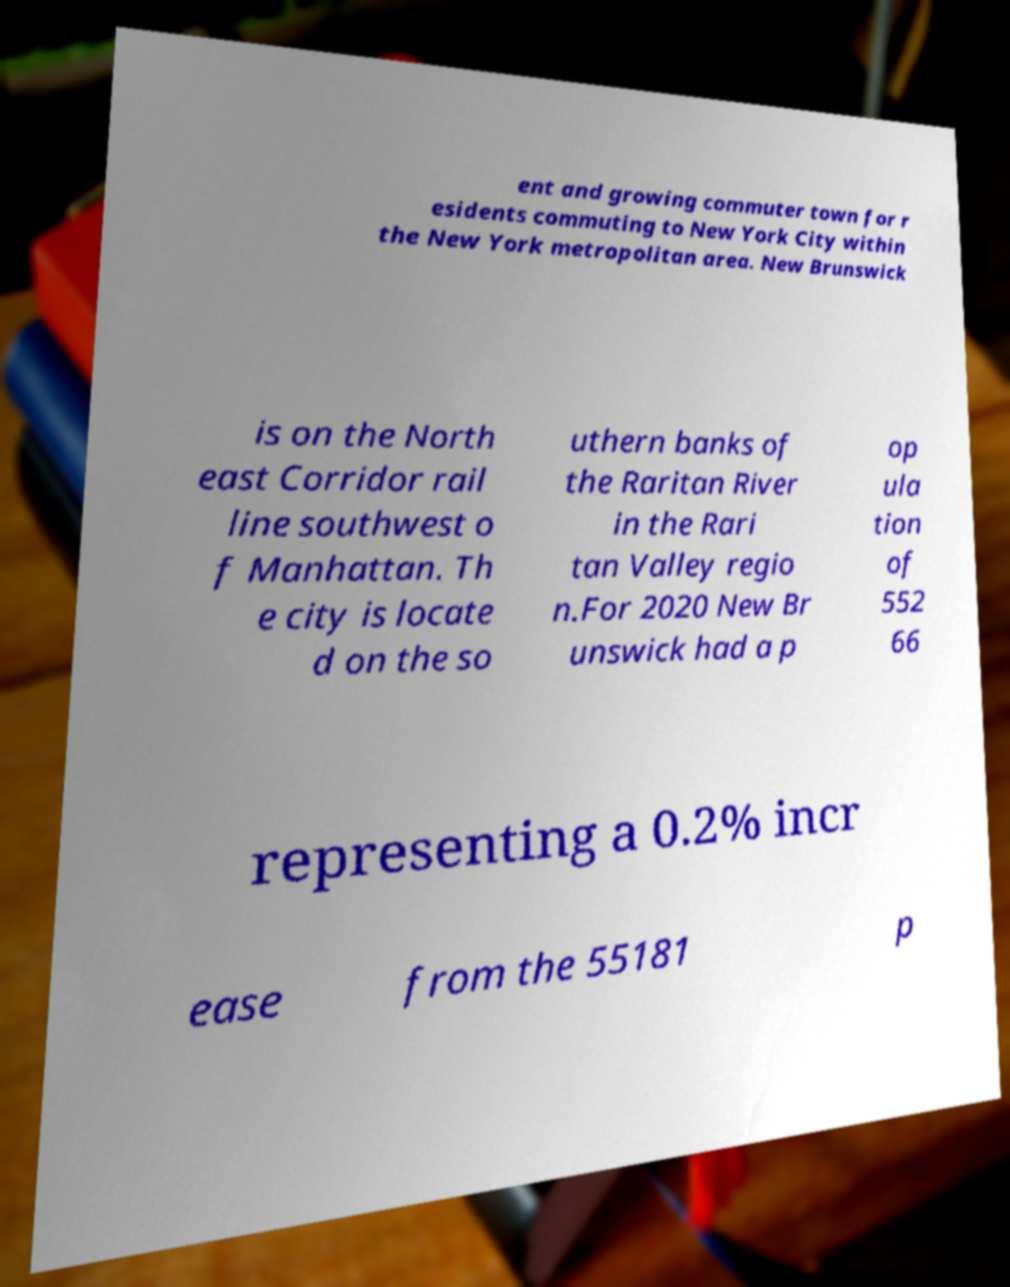There's text embedded in this image that I need extracted. Can you transcribe it verbatim? ent and growing commuter town for r esidents commuting to New York City within the New York metropolitan area. New Brunswick is on the North east Corridor rail line southwest o f Manhattan. Th e city is locate d on the so uthern banks of the Raritan River in the Rari tan Valley regio n.For 2020 New Br unswick had a p op ula tion of 552 66 representing a 0.2% incr ease from the 55181 p 